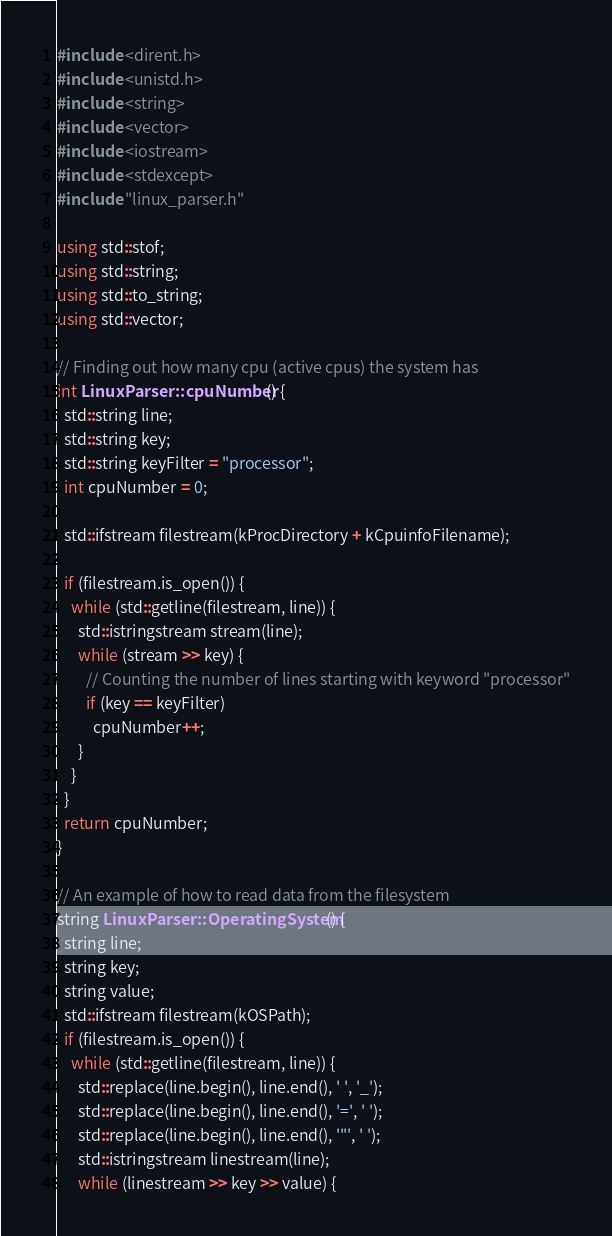Convert code to text. <code><loc_0><loc_0><loc_500><loc_500><_C++_>#include <dirent.h>
#include <unistd.h>
#include <string>
#include <vector>
#include <iostream>
#include <stdexcept>
#include "linux_parser.h"

using std::stof;
using std::string;
using std::to_string;
using std::vector;

// Finding out how many cpu (active cpus) the system has
int LinuxParser::cpuNumber() {
  std::string line;
  std::string key;
  std::string keyFilter = "processor";  
  int cpuNumber = 0;

  std::ifstream filestream(kProcDirectory + kCpuinfoFilename);

  if (filestream.is_open()) {
    while (std::getline(filestream, line)) {
      std::istringstream stream(line);
      while (stream >> key) {
        // Counting the number of lines starting with keyword "processor"
        if (key == keyFilter) 
          cpuNumber++; 
      }    
    }
  }
  return cpuNumber;  
}

// An example of how to read data from the filesystem
string LinuxParser::OperatingSystem() {
  string line;
  string key;
  string value;
  std::ifstream filestream(kOSPath);
  if (filestream.is_open()) {
    while (std::getline(filestream, line)) {
      std::replace(line.begin(), line.end(), ' ', '_');
      std::replace(line.begin(), line.end(), '=', ' ');
      std::replace(line.begin(), line.end(), '"', ' ');
      std::istringstream linestream(line);
      while (linestream >> key >> value) {</code> 